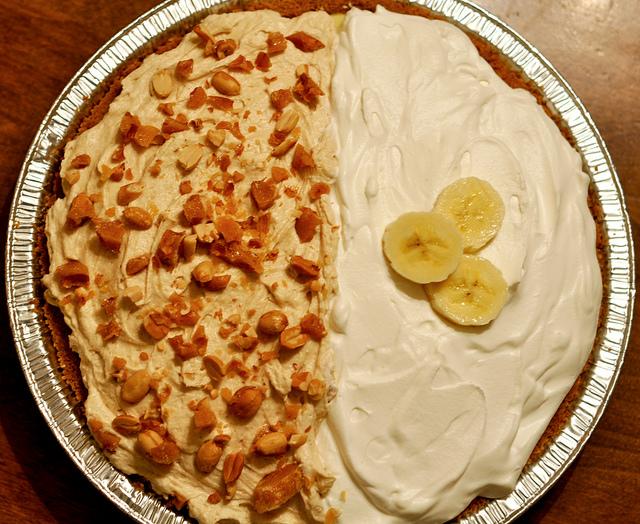What kind of food is in this pan?
Concise answer only. Pie. How many bananas are on the pie?
Be succinct. 3. Does this pie look odd?
Be succinct. Yes. 